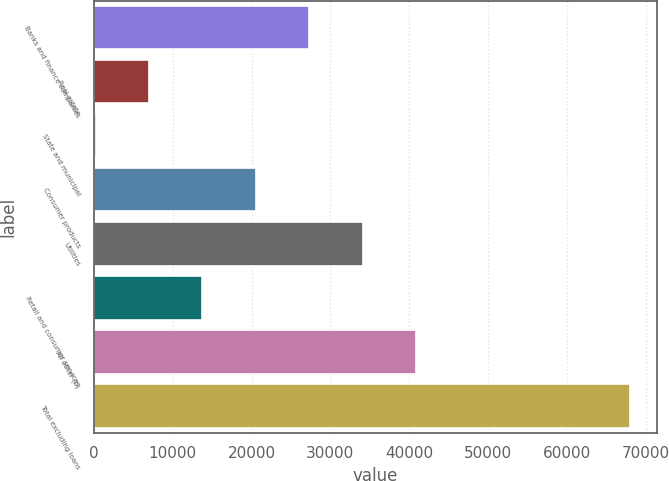<chart> <loc_0><loc_0><loc_500><loc_500><bar_chart><fcel>Banks and finance companies<fcel>Real estate<fcel>State and municipal<fcel>Consumer products<fcel>Utilities<fcel>Retail and consumer services<fcel>All other (b)<fcel>Total excluding loans<nl><fcel>27315.4<fcel>6973.6<fcel>193<fcel>20534.8<fcel>34096<fcel>13754.2<fcel>40876.6<fcel>67999<nl></chart> 